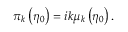<formula> <loc_0><loc_0><loc_500><loc_500>\pi _ { k } \left ( \eta _ { 0 } \right ) = i k \mu _ { k } \left ( \eta _ { 0 } \right ) .</formula> 